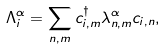<formula> <loc_0><loc_0><loc_500><loc_500>\Lambda _ { i } ^ { \alpha } = \sum _ { n , m } c ^ { \dagger } _ { i , m } \lambda ^ { \alpha } _ { n , m } c _ { i , n } ,</formula> 